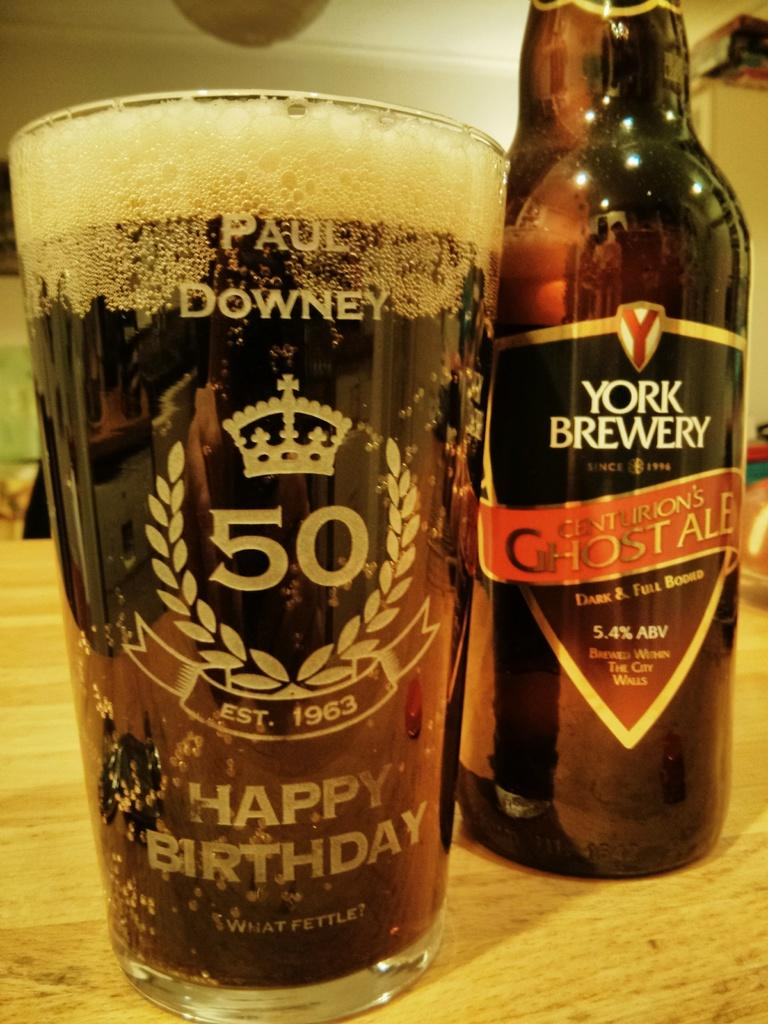<image>
Describe the image concisely. A cup of beer that says happy birthday on it. 